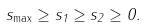Convert formula to latex. <formula><loc_0><loc_0><loc_500><loc_500>s _ { \max } \geq { s _ { 1 } } \geq { s _ { 2 } } \geq 0 .</formula> 